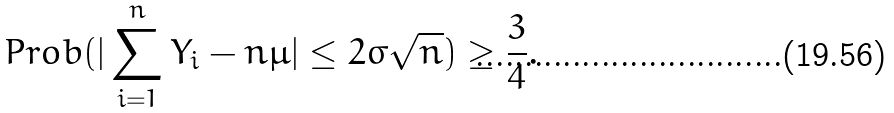Convert formula to latex. <formula><loc_0><loc_0><loc_500><loc_500>P r o b ( | \sum _ { i = 1 } ^ { n } Y _ { i } - n \mu | \leq 2 \sigma \sqrt { n } ) \geq \frac { 3 } { 4 } .</formula> 